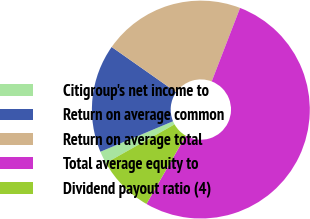Convert chart. <chart><loc_0><loc_0><loc_500><loc_500><pie_chart><fcel>Citigroup's net income to<fcel>Return on average common<fcel>Return on average total<fcel>Total average equity to<fcel>Dividend payout ratio (4)<nl><fcel>1.84%<fcel>16.07%<fcel>21.12%<fcel>52.46%<fcel>8.51%<nl></chart> 